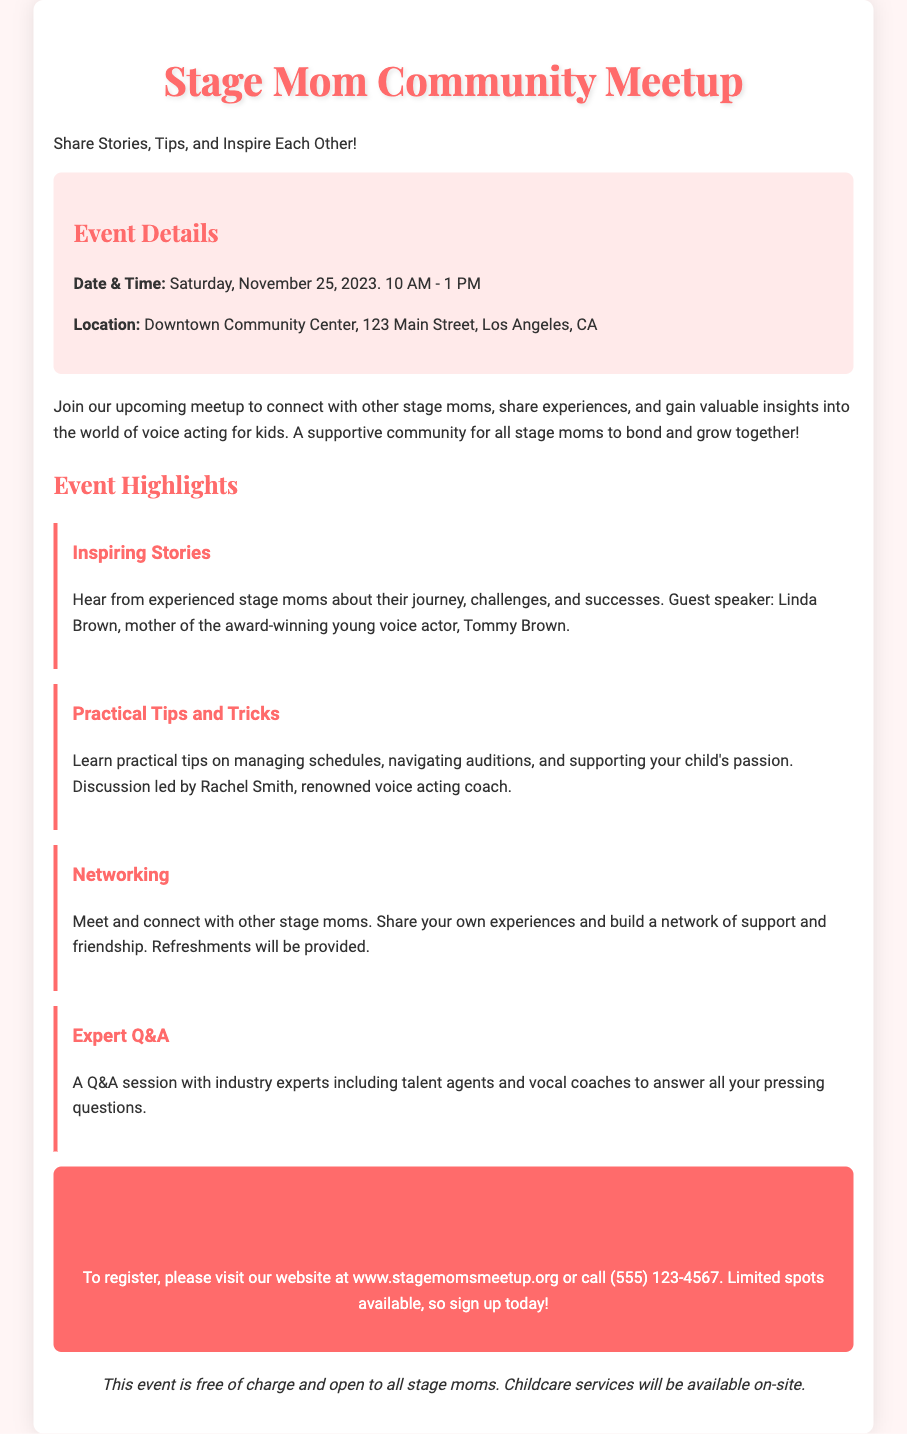What is the date of the event? The date of the event is stated clearly in the document as Saturday, November 25, 2023.
Answer: Saturday, November 25, 2023 What time does the meetup start? The document specifies the start time of the meetup, which is 10 AM.
Answer: 10 AM Who is the guest speaker? The document mentions Linda Brown as the guest speaker and provides information about her connection to an award-winning young voice actor.
Answer: Linda Brown What is the location of the event? The meeting's location is provided in the document as Downtown Community Center, 123 Main Street, Los Angeles, CA.
Answer: Downtown Community Center, 123 Main Street, Los Angeles, CA What will be provided at the networking session? The document states that refreshments will be provided during the networking session of the meetup.
Answer: Refreshments What type of expert will be present for the Q&A session? The document mentions that industry experts including talent agents and vocal coaches will be present for the Q&A session.
Answer: Talent agents and vocal coaches How can one register for the event? The document indicates that registration can be done by visiting the website or calling a specified phone number.
Answer: Visit www.stagemomsmeetup.org or call (555) 123-4567 Is there a cost to attend the event? The document explicitly states that the event is free of charge.
Answer: Free of charge What service will be available on-site for children? The document mentions that childcare services will be available on-site during the event.
Answer: Childcare services 